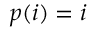<formula> <loc_0><loc_0><loc_500><loc_500>p ( i ) = i</formula> 